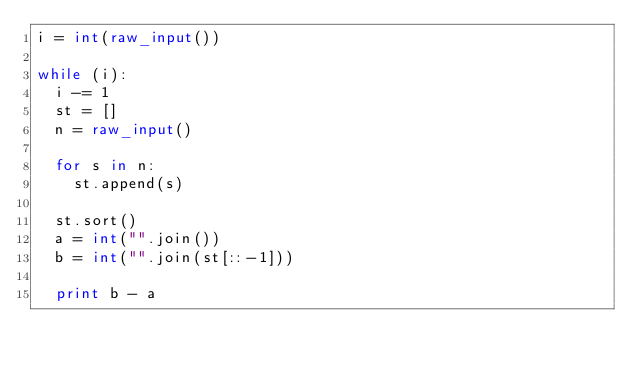Convert code to text. <code><loc_0><loc_0><loc_500><loc_500><_Python_>i = int(raw_input())

while (i):
	i -= 1
	st = []
	n = raw_input()

	for s in n:
		st.append(s)

	st.sort()
	a = int("".join())
	b = int("".join(st[::-1]))

	print b - a</code> 